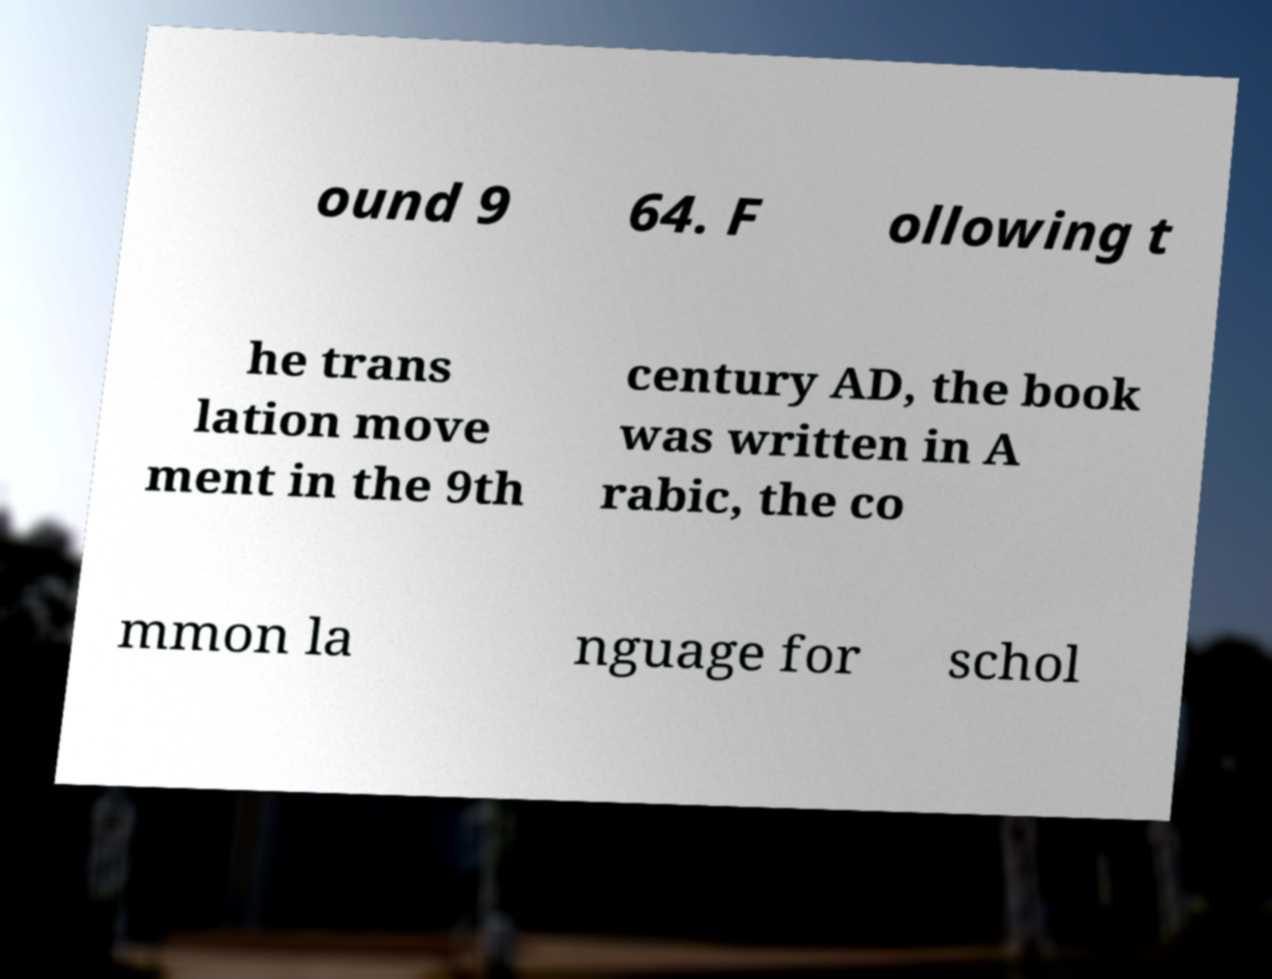Could you assist in decoding the text presented in this image and type it out clearly? ound 9 64. F ollowing t he trans lation move ment in the 9th century AD, the book was written in A rabic, the co mmon la nguage for schol 